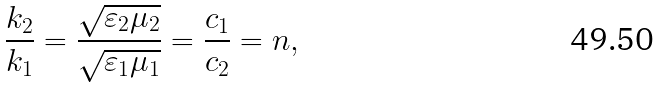<formula> <loc_0><loc_0><loc_500><loc_500>\frac { k _ { 2 } } { k _ { 1 } } = \frac { \sqrt { \varepsilon _ { 2 } \mu _ { 2 } } } { \sqrt { \varepsilon _ { 1 } \mu _ { 1 } } } = \frac { c _ { 1 } } { c _ { 2 } } = n ,</formula> 